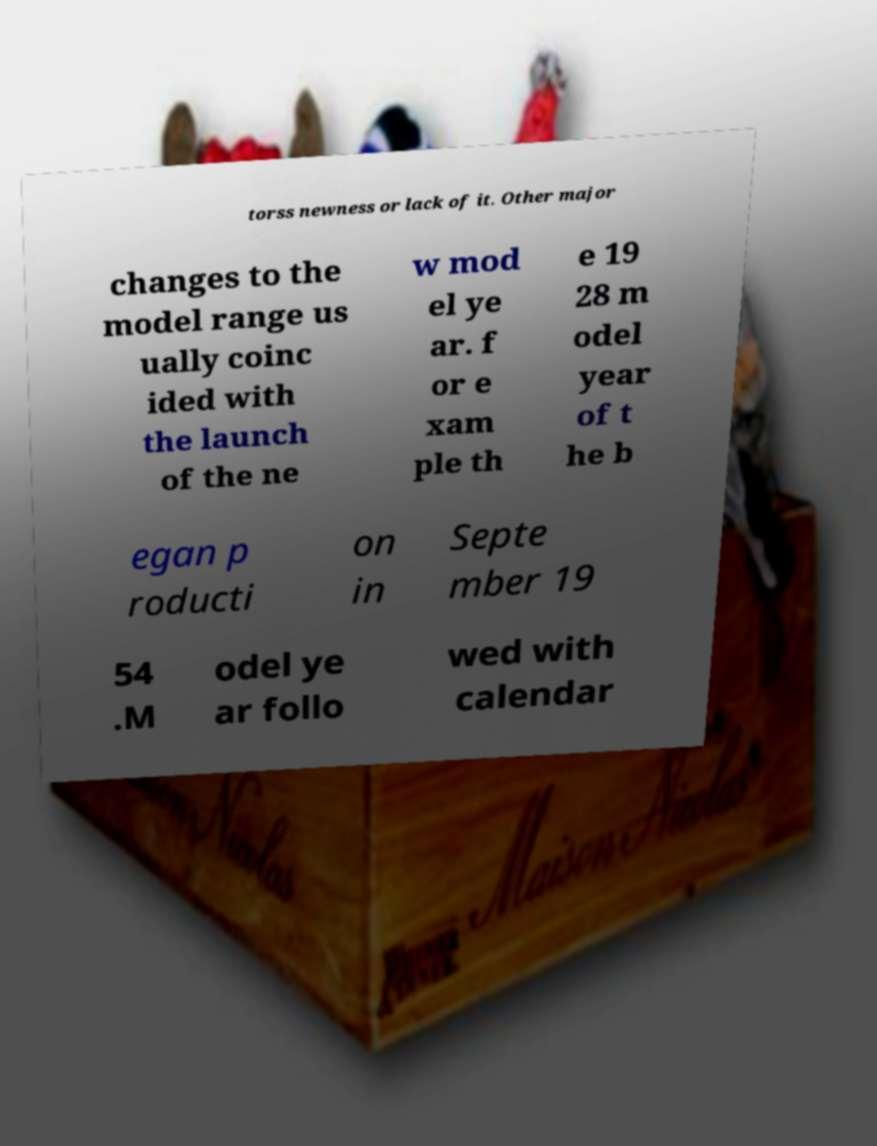Could you extract and type out the text from this image? torss newness or lack of it. Other major changes to the model range us ually coinc ided with the launch of the ne w mod el ye ar. f or e xam ple th e 19 28 m odel year of t he b egan p roducti on in Septe mber 19 54 .M odel ye ar follo wed with calendar 